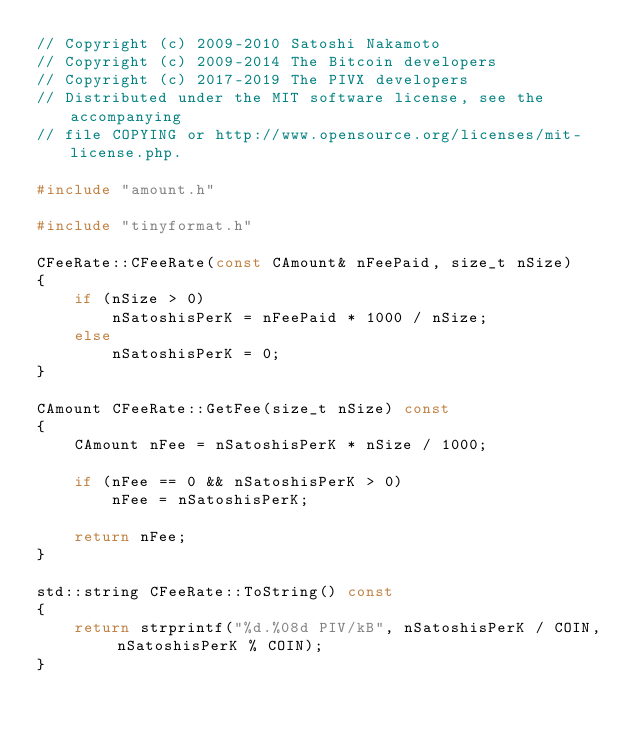<code> <loc_0><loc_0><loc_500><loc_500><_C++_>// Copyright (c) 2009-2010 Satoshi Nakamoto
// Copyright (c) 2009-2014 The Bitcoin developers
// Copyright (c) 2017-2019 The PIVX developers
// Distributed under the MIT software license, see the accompanying
// file COPYING or http://www.opensource.org/licenses/mit-license.php.

#include "amount.h"

#include "tinyformat.h"

CFeeRate::CFeeRate(const CAmount& nFeePaid, size_t nSize)
{
    if (nSize > 0)
        nSatoshisPerK = nFeePaid * 1000 / nSize;
    else
        nSatoshisPerK = 0;
}

CAmount CFeeRate::GetFee(size_t nSize) const
{
    CAmount nFee = nSatoshisPerK * nSize / 1000;

    if (nFee == 0 && nSatoshisPerK > 0)
        nFee = nSatoshisPerK;

    return nFee;
}

std::string CFeeRate::ToString() const
{
    return strprintf("%d.%08d PIV/kB", nSatoshisPerK / COIN, nSatoshisPerK % COIN);
}
</code> 